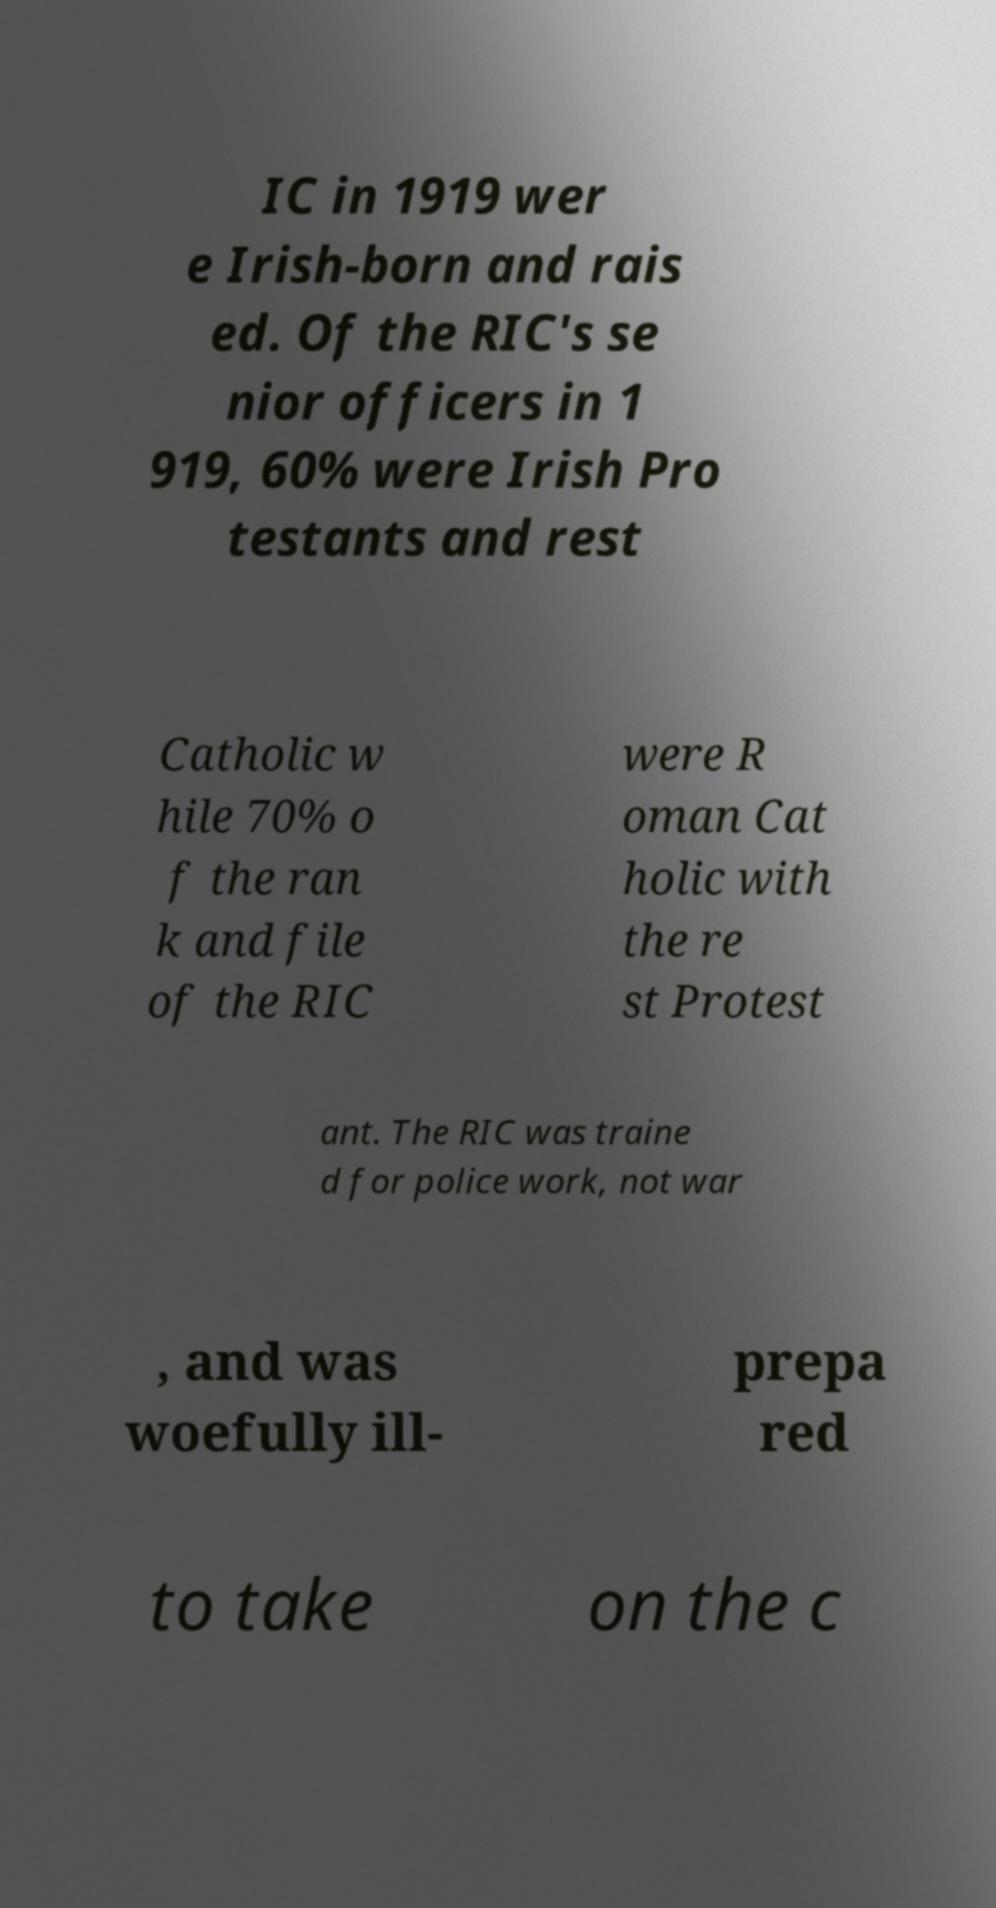I need the written content from this picture converted into text. Can you do that? IC in 1919 wer e Irish-born and rais ed. Of the RIC's se nior officers in 1 919, 60% were Irish Pro testants and rest Catholic w hile 70% o f the ran k and file of the RIC were R oman Cat holic with the re st Protest ant. The RIC was traine d for police work, not war , and was woefully ill- prepa red to take on the c 